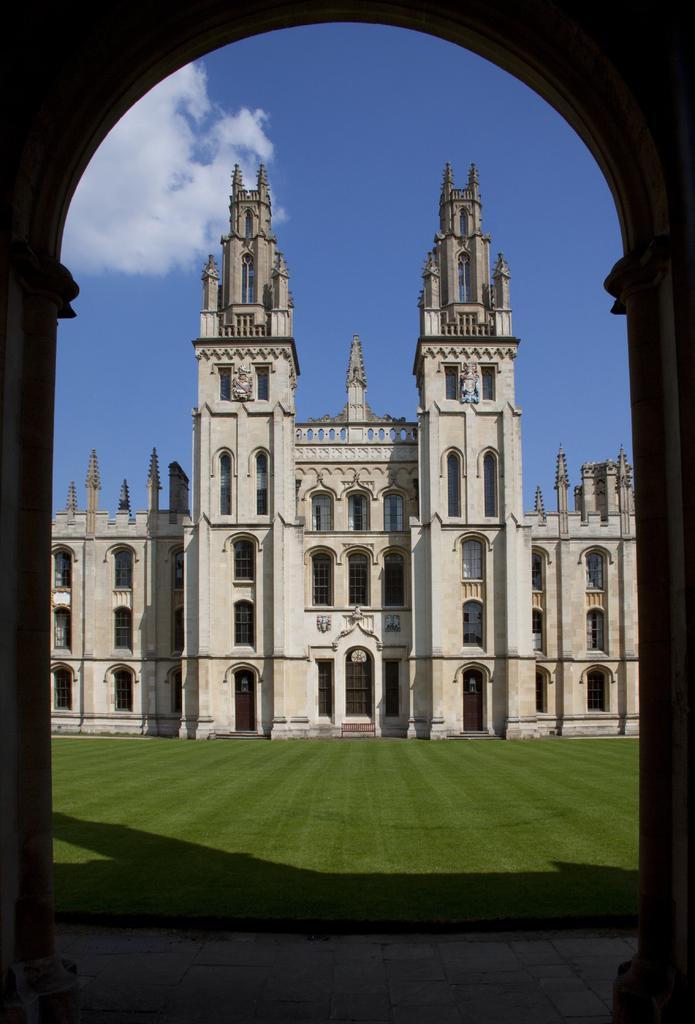Describe this image in one or two sentences. In this image, we can see an arch. Through the arch, we can see building, walls, windows, doors, stairs, pillars, grass and sky. At the bottom of the image, we can see the walkway. 